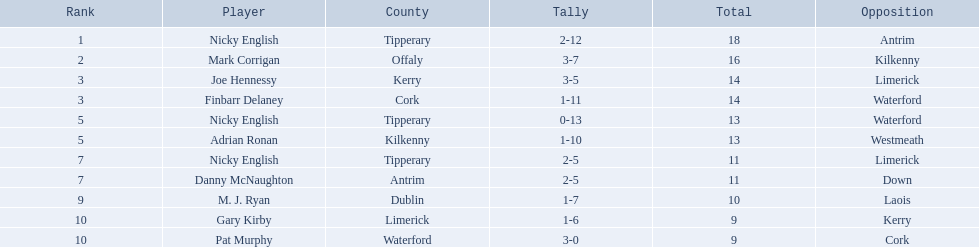Which figures can be found in the total column? 18, 16, 14, 14, 13, 13, 11, 11, 10, 9, 9. In the total column, which row contains the number 10? 9, M. J. Ryan, Dublin, 1-7, 10, Laois. What is the player's name in that particular row? M. J. Ryan. Can you give me this table in json format? {'header': ['Rank', 'Player', 'County', 'Tally', 'Total', 'Opposition'], 'rows': [['1', 'Nicky English', 'Tipperary', '2-12', '18', 'Antrim'], ['2', 'Mark Corrigan', 'Offaly', '3-7', '16', 'Kilkenny'], ['3', 'Joe Hennessy', 'Kerry', '3-5', '14', 'Limerick'], ['3', 'Finbarr Delaney', 'Cork', '1-11', '14', 'Waterford'], ['5', 'Nicky English', 'Tipperary', '0-13', '13', 'Waterford'], ['5', 'Adrian Ronan', 'Kilkenny', '1-10', '13', 'Westmeath'], ['7', 'Nicky English', 'Tipperary', '2-5', '11', 'Limerick'], ['7', 'Danny McNaughton', 'Antrim', '2-5', '11', 'Down'], ['9', 'M. J. Ryan', 'Dublin', '1-7', '10', 'Laois'], ['10', 'Gary Kirby', 'Limerick', '1-6', '9', 'Kerry'], ['10', 'Pat Murphy', 'Waterford', '3-0', '9', 'Cork']]} Who are the players in question? Nicky English, Mark Corrigan, Joe Hennessy, Finbarr Delaney, Nicky English, Adrian Ronan, Nicky English, Danny McNaughton, M. J. Ryan, Gary Kirby, Pat Murphy. How many points were they given? 18, 16, 14, 14, 13, 13, 11, 11, 10, 9, 9. And which among them achieved 10 points? M. J. Ryan. 